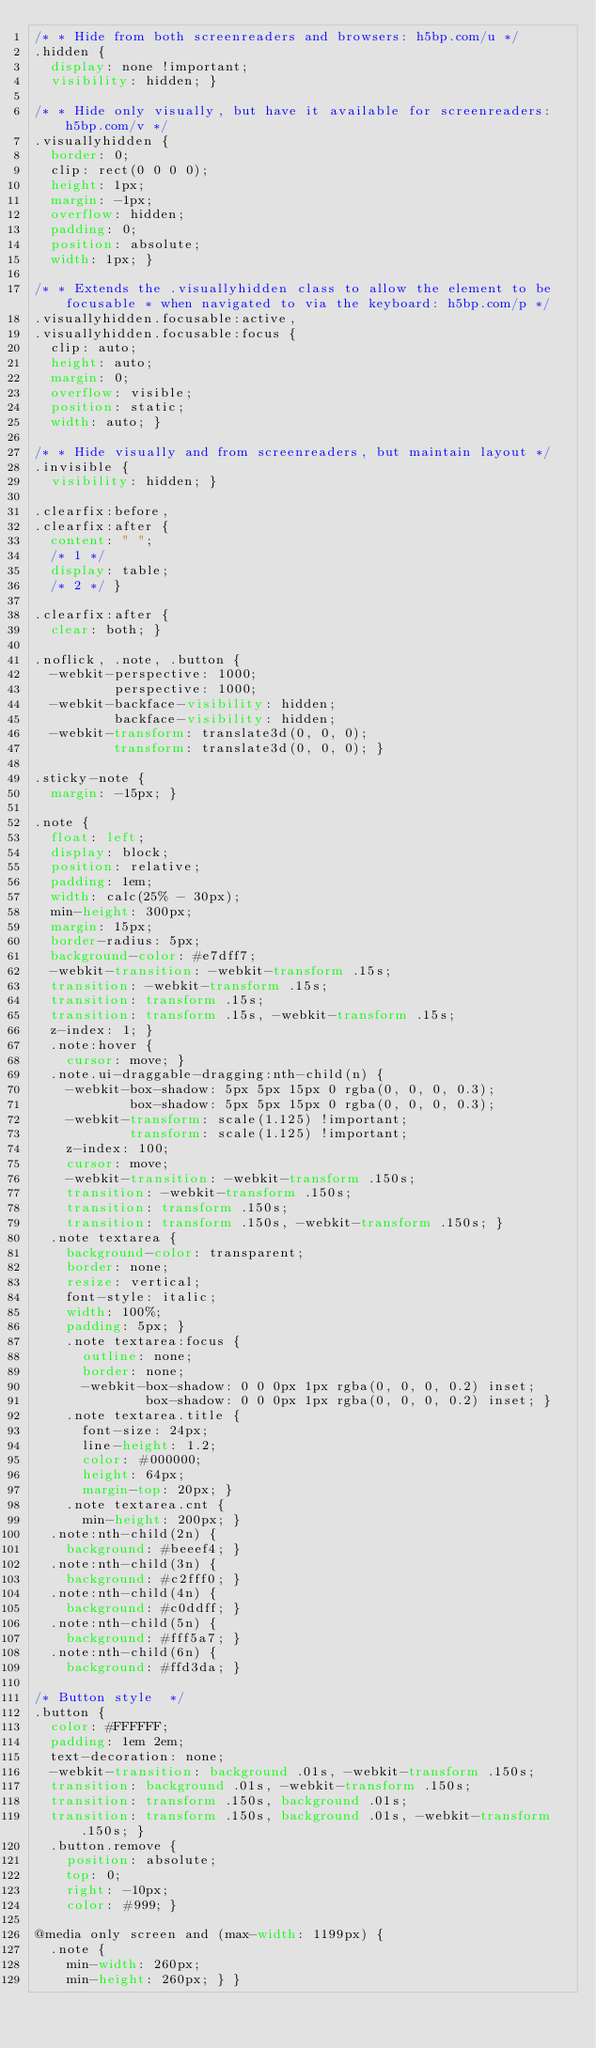<code> <loc_0><loc_0><loc_500><loc_500><_CSS_>/* * Hide from both screenreaders and browsers: h5bp.com/u */
.hidden {
  display: none !important;
  visibility: hidden; }

/* * Hide only visually, but have it available for screenreaders: h5bp.com/v */
.visuallyhidden {
  border: 0;
  clip: rect(0 0 0 0);
  height: 1px;
  margin: -1px;
  overflow: hidden;
  padding: 0;
  position: absolute;
  width: 1px; }

/* * Extends the .visuallyhidden class to allow the element to be focusable * when navigated to via the keyboard: h5bp.com/p */
.visuallyhidden.focusable:active,
.visuallyhidden.focusable:focus {
  clip: auto;
  height: auto;
  margin: 0;
  overflow: visible;
  position: static;
  width: auto; }

/* * Hide visually and from screenreaders, but maintain layout */
.invisible {
  visibility: hidden; }

.clearfix:before,
.clearfix:after {
  content: " ";
  /* 1 */
  display: table;
  /* 2 */ }

.clearfix:after {
  clear: both; }

.noflick, .note, .button {
  -webkit-perspective: 1000;
          perspective: 1000;
  -webkit-backface-visibility: hidden;
          backface-visibility: hidden;
  -webkit-transform: translate3d(0, 0, 0);
          transform: translate3d(0, 0, 0); }

.sticky-note {
  margin: -15px; }

.note {
  float: left;
  display: block;
  position: relative;
  padding: 1em;
  width: calc(25% - 30px);
  min-height: 300px;
  margin: 15px;
  border-radius: 5px;
  background-color: #e7dff7;
  -webkit-transition: -webkit-transform .15s;
  transition: -webkit-transform .15s;
  transition: transform .15s;
  transition: transform .15s, -webkit-transform .15s;
  z-index: 1; }
  .note:hover {
    cursor: move; }
  .note.ui-draggable-dragging:nth-child(n) {
    -webkit-box-shadow: 5px 5px 15px 0 rgba(0, 0, 0, 0.3);
            box-shadow: 5px 5px 15px 0 rgba(0, 0, 0, 0.3);
    -webkit-transform: scale(1.125) !important;
            transform: scale(1.125) !important;
    z-index: 100;
    cursor: move;
    -webkit-transition: -webkit-transform .150s;
    transition: -webkit-transform .150s;
    transition: transform .150s;
    transition: transform .150s, -webkit-transform .150s; }
  .note textarea {
    background-color: transparent;
    border: none;
    resize: vertical;
    font-style: italic;
    width: 100%;
    padding: 5px; }
    .note textarea:focus {
      outline: none;
      border: none;
      -webkit-box-shadow: 0 0 0px 1px rgba(0, 0, 0, 0.2) inset;
              box-shadow: 0 0 0px 1px rgba(0, 0, 0, 0.2) inset; }
    .note textarea.title {
      font-size: 24px;
      line-height: 1.2;
      color: #000000;
      height: 64px;
      margin-top: 20px; }
    .note textarea.cnt {
      min-height: 200px; }
  .note:nth-child(2n) {
    background: #beeef4; }
  .note:nth-child(3n) {
    background: #c2fff0; }
  .note:nth-child(4n) {
    background: #c0ddff; }
  .note:nth-child(5n) {
    background: #fff5a7; }
  .note:nth-child(6n) {
    background: #ffd3da; }

/* Button style  */
.button {
  color: #FFFFFF;
  padding: 1em 2em;
  text-decoration: none;
  -webkit-transition: background .01s, -webkit-transform .150s;
  transition: background .01s, -webkit-transform .150s;
  transition: transform .150s, background .01s;
  transition: transform .150s, background .01s, -webkit-transform .150s; }
  .button.remove {
    position: absolute;
    top: 0;
    right: -10px;
    color: #999; }

@media only screen and (max-width: 1199px) {
  .note {
    min-width: 260px;
    min-height: 260px; } }
</code> 